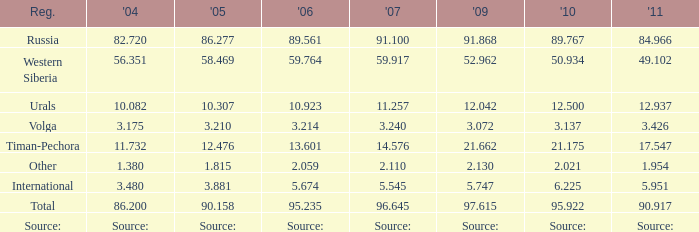What is the 2007 Lukoil oil prodroduction when in 2010 oil production 3.137 million tonnes? 3.24. 